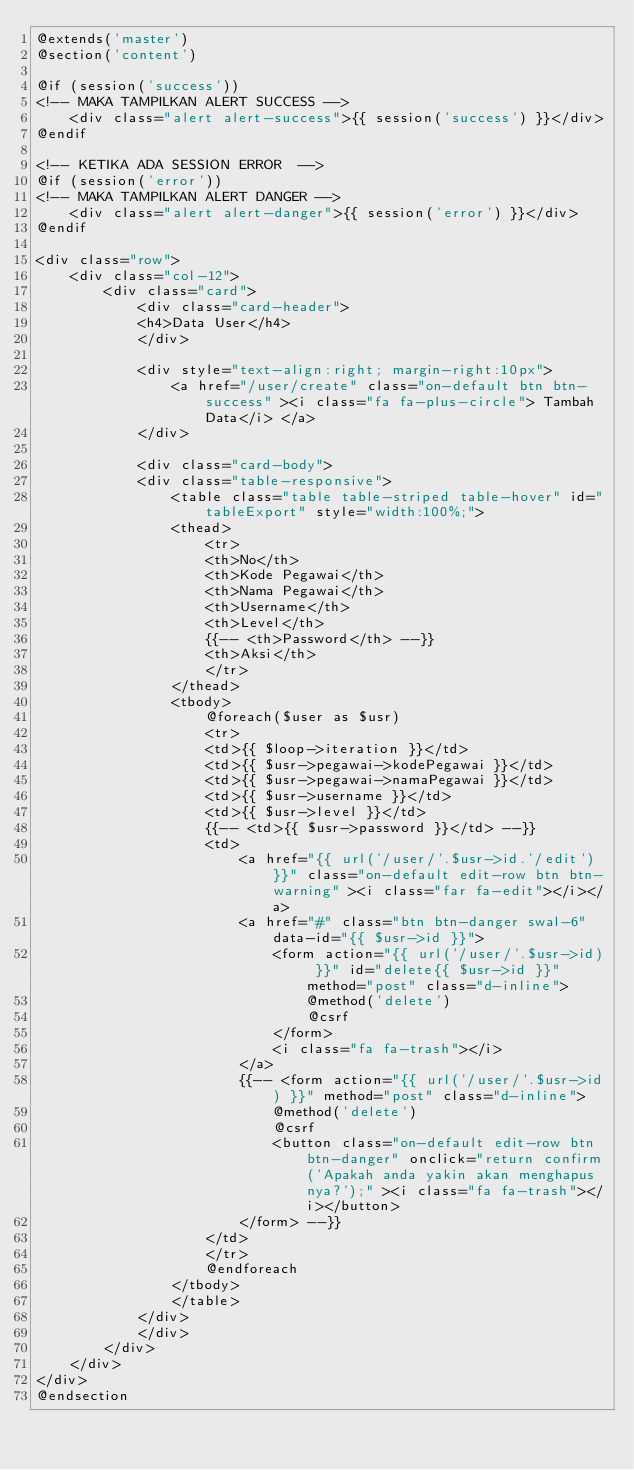Convert code to text. <code><loc_0><loc_0><loc_500><loc_500><_PHP_>@extends('master')
@section('content')

@if (session('success'))
<!-- MAKA TAMPILKAN ALERT SUCCESS -->
    <div class="alert alert-success">{{ session('success') }}</div>
@endif

<!-- KETIKA ADA SESSION ERROR  -->
@if (session('error'))
<!-- MAKA TAMPILKAN ALERT DANGER -->
    <div class="alert alert-danger">{{ session('error') }}</div>
@endif

<div class="row">
    <div class="col-12">
        <div class="card">
            <div class="card-header">
            <h4>Data User</h4>
            </div>

            <div style="text-align:right; margin-right:10px">
                <a href="/user/create" class="on-default btn btn-success" ><i class="fa fa-plus-circle"> Tambah Data</i> </a>
            </div>

            <div class="card-body">
            <div class="table-responsive">
                <table class="table table-striped table-hover" id="tableExport" style="width:100%;">
                <thead>
                    <tr>
                    <th>No</th>
                    <th>Kode Pegawai</th>
                    <th>Nama Pegawai</th>
                    <th>Username</th>
                    <th>Level</th>
                    {{-- <th>Password</th> --}}
                    <th>Aksi</th>
                    </tr>
                </thead>
                <tbody>
                    @foreach($user as $usr)
                    <tr>
                    <td>{{ $loop->iteration }}</td>
                    <td>{{ $usr->pegawai->kodePegawai }}</td>
                    <td>{{ $usr->pegawai->namaPegawai }}</td>
                    <td>{{ $usr->username }}</td>
                    <td>{{ $usr->level }}</td>
                    {{-- <td>{{ $usr->password }}</td> --}}
                    <td>
                        <a href="{{ url('/user/'.$usr->id.'/edit') }}" class="on-default edit-row btn btn-warning" ><i class="far fa-edit"></i></a>
                        <a href="#" class="btn btn-danger swal-6" data-id="{{ $usr->id }}">
                            <form action="{{ url('/user/'.$usr->id) }}" id="delete{{ $usr->id }}" method="post" class="d-inline">
                                @method('delete')
                                @csrf
                            </form>
                            <i class="fa fa-trash"></i>
                        </a>
                        {{-- <form action="{{ url('/user/'.$usr->id) }}" method="post" class="d-inline">
                            @method('delete')
                            @csrf
                            <button class="on-default edit-row btn btn-danger" onclick="return confirm('Apakah anda yakin akan menghapus nya?');" ><i class="fa fa-trash"></i></button>
                        </form> --}}
                    </td>
                    </tr>
                    @endforeach
                </tbody>
                </table>
            </div>
            </div>
        </div>
    </div>
</div>
@endsection
</code> 